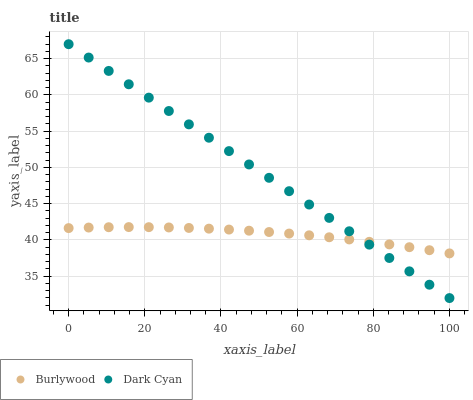Does Burlywood have the minimum area under the curve?
Answer yes or no. Yes. Does Dark Cyan have the maximum area under the curve?
Answer yes or no. Yes. Does Dark Cyan have the minimum area under the curve?
Answer yes or no. No. Is Dark Cyan the smoothest?
Answer yes or no. Yes. Is Burlywood the roughest?
Answer yes or no. Yes. Is Dark Cyan the roughest?
Answer yes or no. No. Does Dark Cyan have the lowest value?
Answer yes or no. Yes. Does Dark Cyan have the highest value?
Answer yes or no. Yes. Does Burlywood intersect Dark Cyan?
Answer yes or no. Yes. Is Burlywood less than Dark Cyan?
Answer yes or no. No. Is Burlywood greater than Dark Cyan?
Answer yes or no. No. 